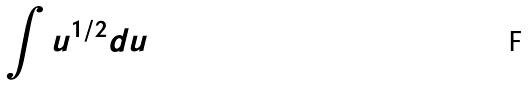Convert formula to latex. <formula><loc_0><loc_0><loc_500><loc_500>\int u ^ { 1 / 2 } d u</formula> 